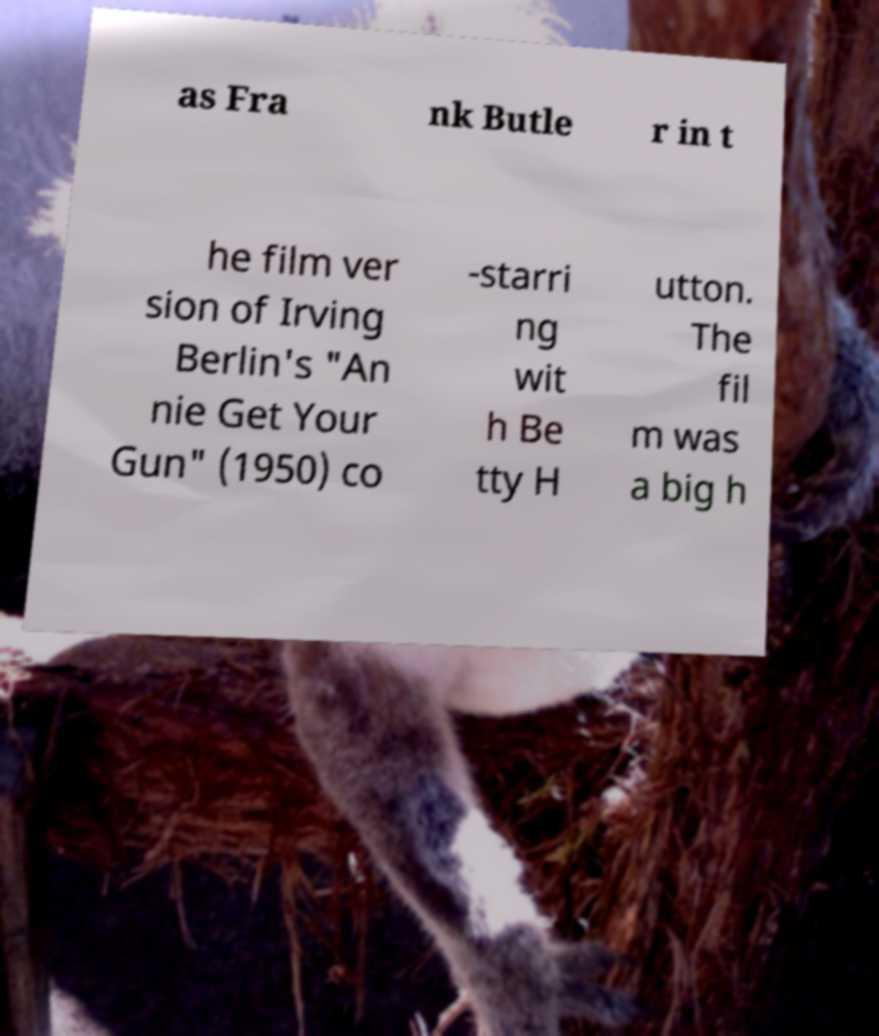Could you assist in decoding the text presented in this image and type it out clearly? as Fra nk Butle r in t he film ver sion of Irving Berlin's "An nie Get Your Gun" (1950) co -starri ng wit h Be tty H utton. The fil m was a big h 